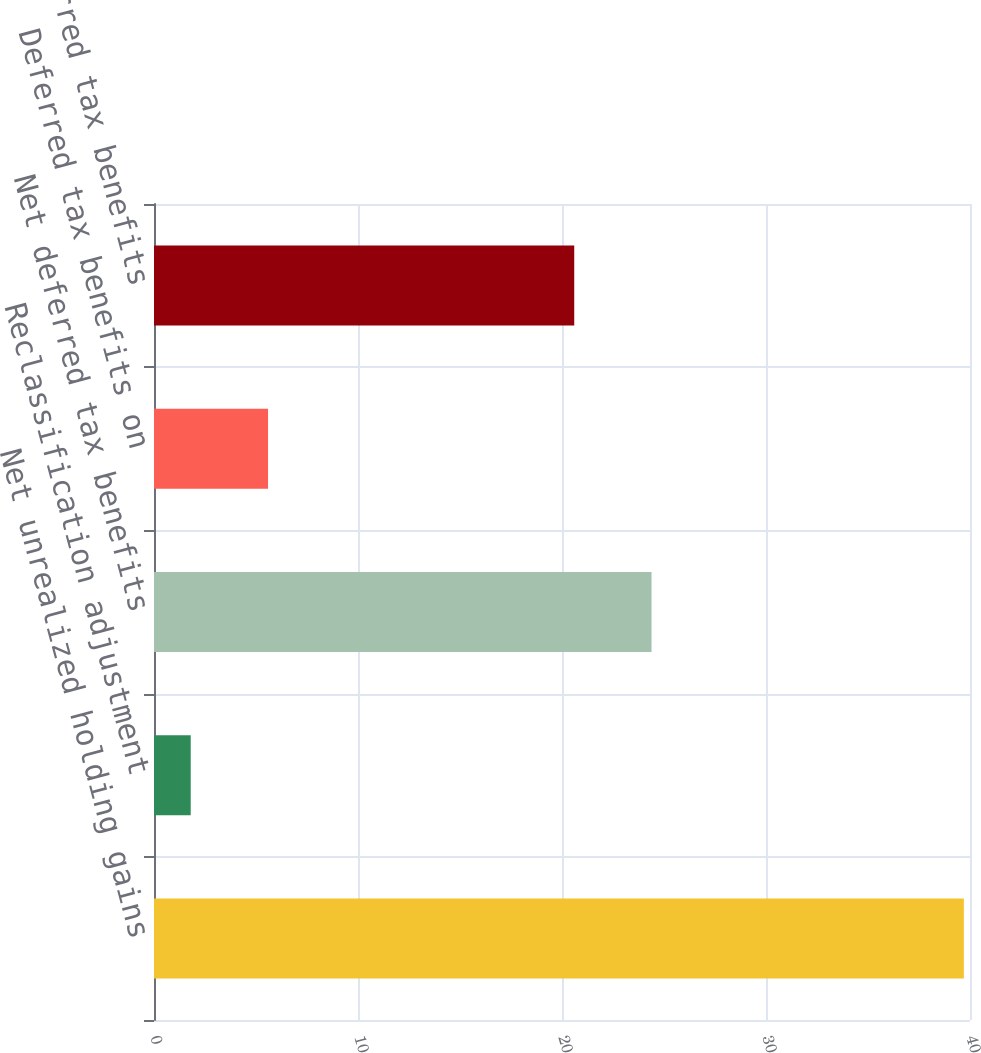Convert chart to OTSL. <chart><loc_0><loc_0><loc_500><loc_500><bar_chart><fcel>Net unrealized holding gains<fcel>Reclassification adjustment<fcel>Net deferred tax benefits<fcel>Deferred tax benefits on<fcel>Total deferred tax benefits<nl><fcel>39.7<fcel>1.8<fcel>24.39<fcel>5.59<fcel>20.6<nl></chart> 